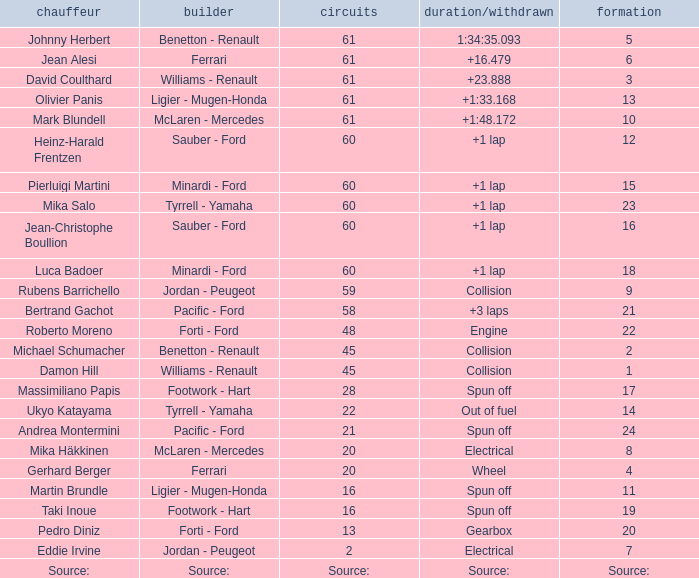What grid has 2 laps? 7.0. 